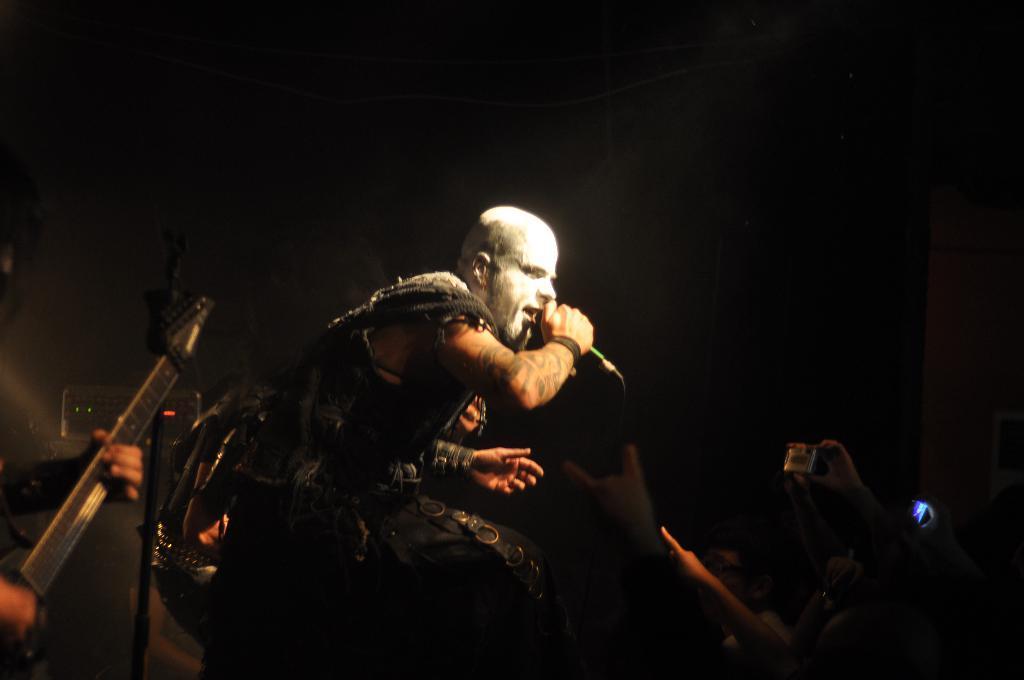How would you summarize this image in a sentence or two? In this picture there is a guy standing on the stage and singing, holding a mic in his hand. There are some people in the down enjoying his music. In the left side there is a guy playing the guitar here.. 